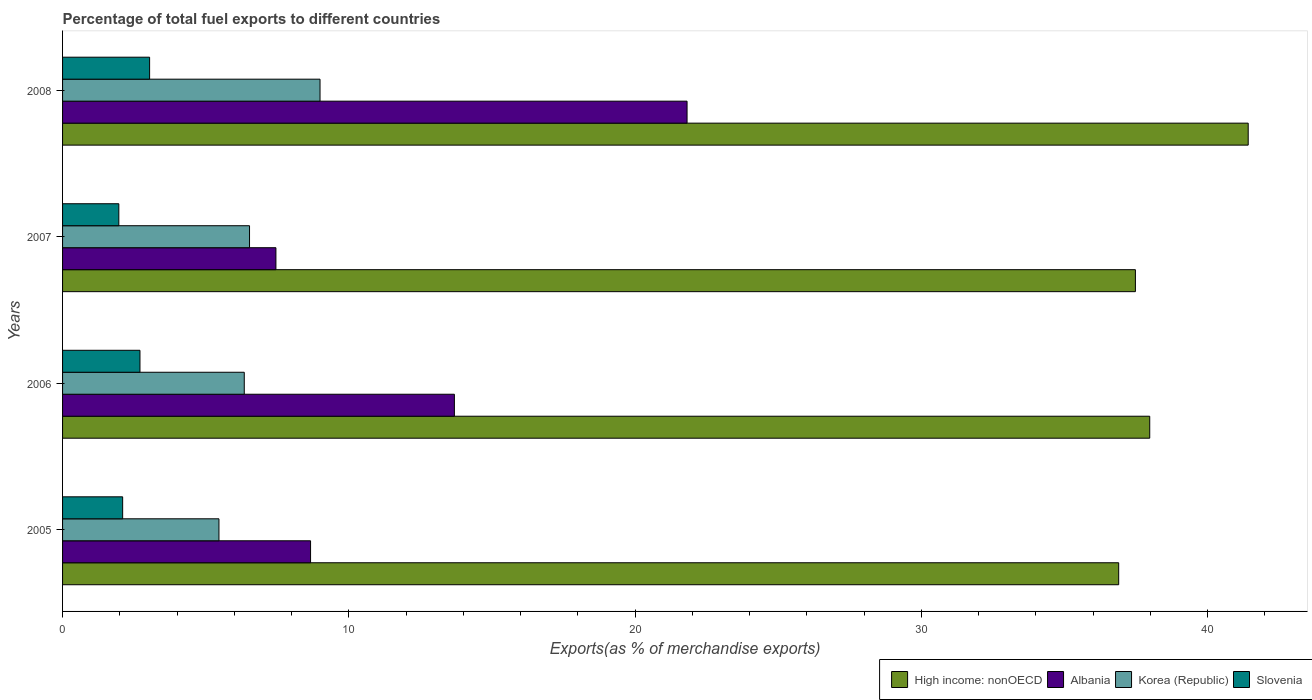Are the number of bars on each tick of the Y-axis equal?
Offer a very short reply. Yes. How many bars are there on the 2nd tick from the top?
Provide a succinct answer. 4. How many bars are there on the 2nd tick from the bottom?
Provide a short and direct response. 4. What is the label of the 3rd group of bars from the top?
Provide a short and direct response. 2006. In how many cases, is the number of bars for a given year not equal to the number of legend labels?
Your answer should be very brief. 0. What is the percentage of exports to different countries in Korea (Republic) in 2005?
Provide a short and direct response. 5.46. Across all years, what is the maximum percentage of exports to different countries in Korea (Republic)?
Offer a very short reply. 8.99. Across all years, what is the minimum percentage of exports to different countries in Korea (Republic)?
Provide a short and direct response. 5.46. In which year was the percentage of exports to different countries in Korea (Republic) maximum?
Provide a short and direct response. 2008. In which year was the percentage of exports to different countries in High income: nonOECD minimum?
Give a very brief answer. 2005. What is the total percentage of exports to different countries in Slovenia in the graph?
Make the answer very short. 9.81. What is the difference between the percentage of exports to different countries in Slovenia in 2005 and that in 2008?
Your response must be concise. -0.94. What is the difference between the percentage of exports to different countries in High income: nonOECD in 2006 and the percentage of exports to different countries in Albania in 2005?
Offer a very short reply. 29.31. What is the average percentage of exports to different countries in Slovenia per year?
Keep it short and to the point. 2.45. In the year 2006, what is the difference between the percentage of exports to different countries in Korea (Republic) and percentage of exports to different countries in High income: nonOECD?
Provide a succinct answer. -31.63. What is the ratio of the percentage of exports to different countries in High income: nonOECD in 2007 to that in 2008?
Offer a terse response. 0.9. Is the percentage of exports to different countries in Korea (Republic) in 2007 less than that in 2008?
Offer a very short reply. Yes. Is the difference between the percentage of exports to different countries in Korea (Republic) in 2005 and 2007 greater than the difference between the percentage of exports to different countries in High income: nonOECD in 2005 and 2007?
Make the answer very short. No. What is the difference between the highest and the second highest percentage of exports to different countries in Korea (Republic)?
Keep it short and to the point. 2.46. What is the difference between the highest and the lowest percentage of exports to different countries in Korea (Republic)?
Your response must be concise. 3.53. In how many years, is the percentage of exports to different countries in Korea (Republic) greater than the average percentage of exports to different countries in Korea (Republic) taken over all years?
Provide a succinct answer. 1. Is the sum of the percentage of exports to different countries in Slovenia in 2005 and 2006 greater than the maximum percentage of exports to different countries in High income: nonOECD across all years?
Provide a short and direct response. No. Is it the case that in every year, the sum of the percentage of exports to different countries in High income: nonOECD and percentage of exports to different countries in Korea (Republic) is greater than the sum of percentage of exports to different countries in Slovenia and percentage of exports to different countries in Albania?
Make the answer very short. No. What does the 4th bar from the top in 2007 represents?
Ensure brevity in your answer.  High income: nonOECD. What does the 4th bar from the bottom in 2007 represents?
Your response must be concise. Slovenia. Is it the case that in every year, the sum of the percentage of exports to different countries in Albania and percentage of exports to different countries in Korea (Republic) is greater than the percentage of exports to different countries in High income: nonOECD?
Your response must be concise. No. Are all the bars in the graph horizontal?
Your answer should be compact. Yes. Does the graph contain grids?
Give a very brief answer. No. What is the title of the graph?
Offer a very short reply. Percentage of total fuel exports to different countries. Does "Bhutan" appear as one of the legend labels in the graph?
Your answer should be very brief. No. What is the label or title of the X-axis?
Make the answer very short. Exports(as % of merchandise exports). What is the Exports(as % of merchandise exports) of High income: nonOECD in 2005?
Keep it short and to the point. 36.89. What is the Exports(as % of merchandise exports) of Albania in 2005?
Make the answer very short. 8.66. What is the Exports(as % of merchandise exports) of Korea (Republic) in 2005?
Your answer should be compact. 5.46. What is the Exports(as % of merchandise exports) of Slovenia in 2005?
Offer a very short reply. 2.1. What is the Exports(as % of merchandise exports) of High income: nonOECD in 2006?
Offer a terse response. 37.98. What is the Exports(as % of merchandise exports) of Albania in 2006?
Provide a succinct answer. 13.69. What is the Exports(as % of merchandise exports) of Korea (Republic) in 2006?
Give a very brief answer. 6.35. What is the Exports(as % of merchandise exports) of Slovenia in 2006?
Your answer should be compact. 2.7. What is the Exports(as % of merchandise exports) in High income: nonOECD in 2007?
Your answer should be very brief. 37.48. What is the Exports(as % of merchandise exports) in Albania in 2007?
Offer a terse response. 7.45. What is the Exports(as % of merchandise exports) in Korea (Republic) in 2007?
Offer a very short reply. 6.53. What is the Exports(as % of merchandise exports) of Slovenia in 2007?
Provide a succinct answer. 1.97. What is the Exports(as % of merchandise exports) in High income: nonOECD in 2008?
Your answer should be very brief. 41.42. What is the Exports(as % of merchandise exports) of Albania in 2008?
Offer a very short reply. 21.81. What is the Exports(as % of merchandise exports) in Korea (Republic) in 2008?
Offer a very short reply. 8.99. What is the Exports(as % of merchandise exports) of Slovenia in 2008?
Ensure brevity in your answer.  3.04. Across all years, what is the maximum Exports(as % of merchandise exports) in High income: nonOECD?
Your answer should be compact. 41.42. Across all years, what is the maximum Exports(as % of merchandise exports) in Albania?
Keep it short and to the point. 21.81. Across all years, what is the maximum Exports(as % of merchandise exports) in Korea (Republic)?
Keep it short and to the point. 8.99. Across all years, what is the maximum Exports(as % of merchandise exports) of Slovenia?
Your answer should be very brief. 3.04. Across all years, what is the minimum Exports(as % of merchandise exports) in High income: nonOECD?
Keep it short and to the point. 36.89. Across all years, what is the minimum Exports(as % of merchandise exports) of Albania?
Your response must be concise. 7.45. Across all years, what is the minimum Exports(as % of merchandise exports) in Korea (Republic)?
Give a very brief answer. 5.46. Across all years, what is the minimum Exports(as % of merchandise exports) in Slovenia?
Make the answer very short. 1.97. What is the total Exports(as % of merchandise exports) in High income: nonOECD in the graph?
Offer a terse response. 153.76. What is the total Exports(as % of merchandise exports) in Albania in the graph?
Provide a short and direct response. 51.62. What is the total Exports(as % of merchandise exports) in Korea (Republic) in the graph?
Make the answer very short. 27.33. What is the total Exports(as % of merchandise exports) of Slovenia in the graph?
Your answer should be compact. 9.81. What is the difference between the Exports(as % of merchandise exports) in High income: nonOECD in 2005 and that in 2006?
Make the answer very short. -1.08. What is the difference between the Exports(as % of merchandise exports) in Albania in 2005 and that in 2006?
Provide a short and direct response. -5.02. What is the difference between the Exports(as % of merchandise exports) of Korea (Republic) in 2005 and that in 2006?
Provide a succinct answer. -0.88. What is the difference between the Exports(as % of merchandise exports) of Slovenia in 2005 and that in 2006?
Make the answer very short. -0.6. What is the difference between the Exports(as % of merchandise exports) in High income: nonOECD in 2005 and that in 2007?
Give a very brief answer. -0.58. What is the difference between the Exports(as % of merchandise exports) of Albania in 2005 and that in 2007?
Provide a short and direct response. 1.21. What is the difference between the Exports(as % of merchandise exports) in Korea (Republic) in 2005 and that in 2007?
Your answer should be very brief. -1.07. What is the difference between the Exports(as % of merchandise exports) of Slovenia in 2005 and that in 2007?
Your response must be concise. 0.13. What is the difference between the Exports(as % of merchandise exports) of High income: nonOECD in 2005 and that in 2008?
Your answer should be very brief. -4.52. What is the difference between the Exports(as % of merchandise exports) of Albania in 2005 and that in 2008?
Provide a succinct answer. -13.15. What is the difference between the Exports(as % of merchandise exports) in Korea (Republic) in 2005 and that in 2008?
Give a very brief answer. -3.53. What is the difference between the Exports(as % of merchandise exports) of Slovenia in 2005 and that in 2008?
Your response must be concise. -0.94. What is the difference between the Exports(as % of merchandise exports) in High income: nonOECD in 2006 and that in 2007?
Keep it short and to the point. 0.5. What is the difference between the Exports(as % of merchandise exports) in Albania in 2006 and that in 2007?
Keep it short and to the point. 6.23. What is the difference between the Exports(as % of merchandise exports) of Korea (Republic) in 2006 and that in 2007?
Provide a short and direct response. -0.18. What is the difference between the Exports(as % of merchandise exports) in Slovenia in 2006 and that in 2007?
Provide a short and direct response. 0.74. What is the difference between the Exports(as % of merchandise exports) in High income: nonOECD in 2006 and that in 2008?
Your answer should be compact. -3.44. What is the difference between the Exports(as % of merchandise exports) of Albania in 2006 and that in 2008?
Your response must be concise. -8.13. What is the difference between the Exports(as % of merchandise exports) of Korea (Republic) in 2006 and that in 2008?
Provide a succinct answer. -2.65. What is the difference between the Exports(as % of merchandise exports) of Slovenia in 2006 and that in 2008?
Your answer should be compact. -0.34. What is the difference between the Exports(as % of merchandise exports) in High income: nonOECD in 2007 and that in 2008?
Your answer should be compact. -3.94. What is the difference between the Exports(as % of merchandise exports) in Albania in 2007 and that in 2008?
Keep it short and to the point. -14.36. What is the difference between the Exports(as % of merchandise exports) in Korea (Republic) in 2007 and that in 2008?
Offer a very short reply. -2.46. What is the difference between the Exports(as % of merchandise exports) of Slovenia in 2007 and that in 2008?
Offer a terse response. -1.08. What is the difference between the Exports(as % of merchandise exports) in High income: nonOECD in 2005 and the Exports(as % of merchandise exports) in Albania in 2006?
Your answer should be very brief. 23.2. What is the difference between the Exports(as % of merchandise exports) of High income: nonOECD in 2005 and the Exports(as % of merchandise exports) of Korea (Republic) in 2006?
Offer a very short reply. 30.54. What is the difference between the Exports(as % of merchandise exports) in High income: nonOECD in 2005 and the Exports(as % of merchandise exports) in Slovenia in 2006?
Ensure brevity in your answer.  34.19. What is the difference between the Exports(as % of merchandise exports) of Albania in 2005 and the Exports(as % of merchandise exports) of Korea (Republic) in 2006?
Give a very brief answer. 2.32. What is the difference between the Exports(as % of merchandise exports) of Albania in 2005 and the Exports(as % of merchandise exports) of Slovenia in 2006?
Provide a short and direct response. 5.96. What is the difference between the Exports(as % of merchandise exports) in Korea (Republic) in 2005 and the Exports(as % of merchandise exports) in Slovenia in 2006?
Provide a succinct answer. 2.76. What is the difference between the Exports(as % of merchandise exports) in High income: nonOECD in 2005 and the Exports(as % of merchandise exports) in Albania in 2007?
Your response must be concise. 29.44. What is the difference between the Exports(as % of merchandise exports) of High income: nonOECD in 2005 and the Exports(as % of merchandise exports) of Korea (Republic) in 2007?
Give a very brief answer. 30.36. What is the difference between the Exports(as % of merchandise exports) in High income: nonOECD in 2005 and the Exports(as % of merchandise exports) in Slovenia in 2007?
Provide a short and direct response. 34.93. What is the difference between the Exports(as % of merchandise exports) in Albania in 2005 and the Exports(as % of merchandise exports) in Korea (Republic) in 2007?
Your answer should be compact. 2.13. What is the difference between the Exports(as % of merchandise exports) in Albania in 2005 and the Exports(as % of merchandise exports) in Slovenia in 2007?
Your answer should be compact. 6.7. What is the difference between the Exports(as % of merchandise exports) of Korea (Republic) in 2005 and the Exports(as % of merchandise exports) of Slovenia in 2007?
Your response must be concise. 3.5. What is the difference between the Exports(as % of merchandise exports) in High income: nonOECD in 2005 and the Exports(as % of merchandise exports) in Albania in 2008?
Offer a terse response. 15.08. What is the difference between the Exports(as % of merchandise exports) of High income: nonOECD in 2005 and the Exports(as % of merchandise exports) of Korea (Republic) in 2008?
Offer a very short reply. 27.9. What is the difference between the Exports(as % of merchandise exports) of High income: nonOECD in 2005 and the Exports(as % of merchandise exports) of Slovenia in 2008?
Offer a very short reply. 33.85. What is the difference between the Exports(as % of merchandise exports) of Albania in 2005 and the Exports(as % of merchandise exports) of Korea (Republic) in 2008?
Offer a very short reply. -0.33. What is the difference between the Exports(as % of merchandise exports) in Albania in 2005 and the Exports(as % of merchandise exports) in Slovenia in 2008?
Offer a terse response. 5.62. What is the difference between the Exports(as % of merchandise exports) in Korea (Republic) in 2005 and the Exports(as % of merchandise exports) in Slovenia in 2008?
Keep it short and to the point. 2.42. What is the difference between the Exports(as % of merchandise exports) in High income: nonOECD in 2006 and the Exports(as % of merchandise exports) in Albania in 2007?
Your response must be concise. 30.52. What is the difference between the Exports(as % of merchandise exports) in High income: nonOECD in 2006 and the Exports(as % of merchandise exports) in Korea (Republic) in 2007?
Give a very brief answer. 31.45. What is the difference between the Exports(as % of merchandise exports) of High income: nonOECD in 2006 and the Exports(as % of merchandise exports) of Slovenia in 2007?
Give a very brief answer. 36.01. What is the difference between the Exports(as % of merchandise exports) in Albania in 2006 and the Exports(as % of merchandise exports) in Korea (Republic) in 2007?
Provide a succinct answer. 7.16. What is the difference between the Exports(as % of merchandise exports) in Albania in 2006 and the Exports(as % of merchandise exports) in Slovenia in 2007?
Provide a short and direct response. 11.72. What is the difference between the Exports(as % of merchandise exports) in Korea (Republic) in 2006 and the Exports(as % of merchandise exports) in Slovenia in 2007?
Your response must be concise. 4.38. What is the difference between the Exports(as % of merchandise exports) in High income: nonOECD in 2006 and the Exports(as % of merchandise exports) in Albania in 2008?
Give a very brief answer. 16.16. What is the difference between the Exports(as % of merchandise exports) of High income: nonOECD in 2006 and the Exports(as % of merchandise exports) of Korea (Republic) in 2008?
Your response must be concise. 28.98. What is the difference between the Exports(as % of merchandise exports) in High income: nonOECD in 2006 and the Exports(as % of merchandise exports) in Slovenia in 2008?
Offer a terse response. 34.94. What is the difference between the Exports(as % of merchandise exports) in Albania in 2006 and the Exports(as % of merchandise exports) in Korea (Republic) in 2008?
Give a very brief answer. 4.69. What is the difference between the Exports(as % of merchandise exports) of Albania in 2006 and the Exports(as % of merchandise exports) of Slovenia in 2008?
Ensure brevity in your answer.  10.65. What is the difference between the Exports(as % of merchandise exports) in Korea (Republic) in 2006 and the Exports(as % of merchandise exports) in Slovenia in 2008?
Keep it short and to the point. 3.31. What is the difference between the Exports(as % of merchandise exports) of High income: nonOECD in 2007 and the Exports(as % of merchandise exports) of Albania in 2008?
Ensure brevity in your answer.  15.66. What is the difference between the Exports(as % of merchandise exports) in High income: nonOECD in 2007 and the Exports(as % of merchandise exports) in Korea (Republic) in 2008?
Your response must be concise. 28.48. What is the difference between the Exports(as % of merchandise exports) of High income: nonOECD in 2007 and the Exports(as % of merchandise exports) of Slovenia in 2008?
Give a very brief answer. 34.44. What is the difference between the Exports(as % of merchandise exports) of Albania in 2007 and the Exports(as % of merchandise exports) of Korea (Republic) in 2008?
Offer a terse response. -1.54. What is the difference between the Exports(as % of merchandise exports) in Albania in 2007 and the Exports(as % of merchandise exports) in Slovenia in 2008?
Make the answer very short. 4.41. What is the difference between the Exports(as % of merchandise exports) of Korea (Republic) in 2007 and the Exports(as % of merchandise exports) of Slovenia in 2008?
Keep it short and to the point. 3.49. What is the average Exports(as % of merchandise exports) in High income: nonOECD per year?
Provide a succinct answer. 38.44. What is the average Exports(as % of merchandise exports) of Albania per year?
Your response must be concise. 12.9. What is the average Exports(as % of merchandise exports) in Korea (Republic) per year?
Provide a succinct answer. 6.83. What is the average Exports(as % of merchandise exports) of Slovenia per year?
Your response must be concise. 2.45. In the year 2005, what is the difference between the Exports(as % of merchandise exports) of High income: nonOECD and Exports(as % of merchandise exports) of Albania?
Offer a terse response. 28.23. In the year 2005, what is the difference between the Exports(as % of merchandise exports) in High income: nonOECD and Exports(as % of merchandise exports) in Korea (Republic)?
Offer a terse response. 31.43. In the year 2005, what is the difference between the Exports(as % of merchandise exports) in High income: nonOECD and Exports(as % of merchandise exports) in Slovenia?
Provide a short and direct response. 34.79. In the year 2005, what is the difference between the Exports(as % of merchandise exports) in Albania and Exports(as % of merchandise exports) in Korea (Republic)?
Give a very brief answer. 3.2. In the year 2005, what is the difference between the Exports(as % of merchandise exports) in Albania and Exports(as % of merchandise exports) in Slovenia?
Your response must be concise. 6.56. In the year 2005, what is the difference between the Exports(as % of merchandise exports) in Korea (Republic) and Exports(as % of merchandise exports) in Slovenia?
Provide a short and direct response. 3.36. In the year 2006, what is the difference between the Exports(as % of merchandise exports) in High income: nonOECD and Exports(as % of merchandise exports) in Albania?
Offer a terse response. 24.29. In the year 2006, what is the difference between the Exports(as % of merchandise exports) in High income: nonOECD and Exports(as % of merchandise exports) in Korea (Republic)?
Keep it short and to the point. 31.63. In the year 2006, what is the difference between the Exports(as % of merchandise exports) in High income: nonOECD and Exports(as % of merchandise exports) in Slovenia?
Offer a terse response. 35.27. In the year 2006, what is the difference between the Exports(as % of merchandise exports) in Albania and Exports(as % of merchandise exports) in Korea (Republic)?
Your response must be concise. 7.34. In the year 2006, what is the difference between the Exports(as % of merchandise exports) of Albania and Exports(as % of merchandise exports) of Slovenia?
Offer a terse response. 10.98. In the year 2006, what is the difference between the Exports(as % of merchandise exports) in Korea (Republic) and Exports(as % of merchandise exports) in Slovenia?
Give a very brief answer. 3.64. In the year 2007, what is the difference between the Exports(as % of merchandise exports) in High income: nonOECD and Exports(as % of merchandise exports) in Albania?
Provide a succinct answer. 30.02. In the year 2007, what is the difference between the Exports(as % of merchandise exports) in High income: nonOECD and Exports(as % of merchandise exports) in Korea (Republic)?
Make the answer very short. 30.95. In the year 2007, what is the difference between the Exports(as % of merchandise exports) in High income: nonOECD and Exports(as % of merchandise exports) in Slovenia?
Provide a short and direct response. 35.51. In the year 2007, what is the difference between the Exports(as % of merchandise exports) in Albania and Exports(as % of merchandise exports) in Korea (Republic)?
Your answer should be compact. 0.92. In the year 2007, what is the difference between the Exports(as % of merchandise exports) in Albania and Exports(as % of merchandise exports) in Slovenia?
Provide a succinct answer. 5.49. In the year 2007, what is the difference between the Exports(as % of merchandise exports) in Korea (Republic) and Exports(as % of merchandise exports) in Slovenia?
Your response must be concise. 4.57. In the year 2008, what is the difference between the Exports(as % of merchandise exports) of High income: nonOECD and Exports(as % of merchandise exports) of Albania?
Give a very brief answer. 19.6. In the year 2008, what is the difference between the Exports(as % of merchandise exports) of High income: nonOECD and Exports(as % of merchandise exports) of Korea (Republic)?
Give a very brief answer. 32.42. In the year 2008, what is the difference between the Exports(as % of merchandise exports) of High income: nonOECD and Exports(as % of merchandise exports) of Slovenia?
Ensure brevity in your answer.  38.38. In the year 2008, what is the difference between the Exports(as % of merchandise exports) in Albania and Exports(as % of merchandise exports) in Korea (Republic)?
Provide a succinct answer. 12.82. In the year 2008, what is the difference between the Exports(as % of merchandise exports) of Albania and Exports(as % of merchandise exports) of Slovenia?
Your answer should be very brief. 18.77. In the year 2008, what is the difference between the Exports(as % of merchandise exports) of Korea (Republic) and Exports(as % of merchandise exports) of Slovenia?
Give a very brief answer. 5.95. What is the ratio of the Exports(as % of merchandise exports) of High income: nonOECD in 2005 to that in 2006?
Give a very brief answer. 0.97. What is the ratio of the Exports(as % of merchandise exports) of Albania in 2005 to that in 2006?
Your answer should be compact. 0.63. What is the ratio of the Exports(as % of merchandise exports) in Korea (Republic) in 2005 to that in 2006?
Your answer should be very brief. 0.86. What is the ratio of the Exports(as % of merchandise exports) of Slovenia in 2005 to that in 2006?
Your answer should be compact. 0.78. What is the ratio of the Exports(as % of merchandise exports) in High income: nonOECD in 2005 to that in 2007?
Provide a succinct answer. 0.98. What is the ratio of the Exports(as % of merchandise exports) of Albania in 2005 to that in 2007?
Provide a short and direct response. 1.16. What is the ratio of the Exports(as % of merchandise exports) of Korea (Republic) in 2005 to that in 2007?
Keep it short and to the point. 0.84. What is the ratio of the Exports(as % of merchandise exports) of Slovenia in 2005 to that in 2007?
Ensure brevity in your answer.  1.07. What is the ratio of the Exports(as % of merchandise exports) in High income: nonOECD in 2005 to that in 2008?
Your response must be concise. 0.89. What is the ratio of the Exports(as % of merchandise exports) of Albania in 2005 to that in 2008?
Keep it short and to the point. 0.4. What is the ratio of the Exports(as % of merchandise exports) of Korea (Republic) in 2005 to that in 2008?
Offer a very short reply. 0.61. What is the ratio of the Exports(as % of merchandise exports) of Slovenia in 2005 to that in 2008?
Ensure brevity in your answer.  0.69. What is the ratio of the Exports(as % of merchandise exports) in High income: nonOECD in 2006 to that in 2007?
Your response must be concise. 1.01. What is the ratio of the Exports(as % of merchandise exports) of Albania in 2006 to that in 2007?
Keep it short and to the point. 1.84. What is the ratio of the Exports(as % of merchandise exports) in Korea (Republic) in 2006 to that in 2007?
Make the answer very short. 0.97. What is the ratio of the Exports(as % of merchandise exports) in Slovenia in 2006 to that in 2007?
Provide a succinct answer. 1.38. What is the ratio of the Exports(as % of merchandise exports) in High income: nonOECD in 2006 to that in 2008?
Keep it short and to the point. 0.92. What is the ratio of the Exports(as % of merchandise exports) in Albania in 2006 to that in 2008?
Your answer should be very brief. 0.63. What is the ratio of the Exports(as % of merchandise exports) of Korea (Republic) in 2006 to that in 2008?
Offer a very short reply. 0.71. What is the ratio of the Exports(as % of merchandise exports) of Slovenia in 2006 to that in 2008?
Ensure brevity in your answer.  0.89. What is the ratio of the Exports(as % of merchandise exports) in High income: nonOECD in 2007 to that in 2008?
Offer a terse response. 0.9. What is the ratio of the Exports(as % of merchandise exports) of Albania in 2007 to that in 2008?
Offer a very short reply. 0.34. What is the ratio of the Exports(as % of merchandise exports) in Korea (Republic) in 2007 to that in 2008?
Your response must be concise. 0.73. What is the ratio of the Exports(as % of merchandise exports) in Slovenia in 2007 to that in 2008?
Keep it short and to the point. 0.65. What is the difference between the highest and the second highest Exports(as % of merchandise exports) of High income: nonOECD?
Ensure brevity in your answer.  3.44. What is the difference between the highest and the second highest Exports(as % of merchandise exports) in Albania?
Provide a succinct answer. 8.13. What is the difference between the highest and the second highest Exports(as % of merchandise exports) of Korea (Republic)?
Offer a very short reply. 2.46. What is the difference between the highest and the second highest Exports(as % of merchandise exports) of Slovenia?
Your answer should be compact. 0.34. What is the difference between the highest and the lowest Exports(as % of merchandise exports) in High income: nonOECD?
Offer a very short reply. 4.52. What is the difference between the highest and the lowest Exports(as % of merchandise exports) of Albania?
Provide a short and direct response. 14.36. What is the difference between the highest and the lowest Exports(as % of merchandise exports) in Korea (Republic)?
Your answer should be very brief. 3.53. What is the difference between the highest and the lowest Exports(as % of merchandise exports) of Slovenia?
Offer a terse response. 1.08. 